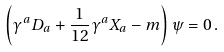<formula> <loc_0><loc_0><loc_500><loc_500>\left ( \gamma ^ { a } D _ { a } + \frac { 1 } { 1 2 } \gamma ^ { a } X _ { a } - m \right ) \psi = 0 \, .</formula> 